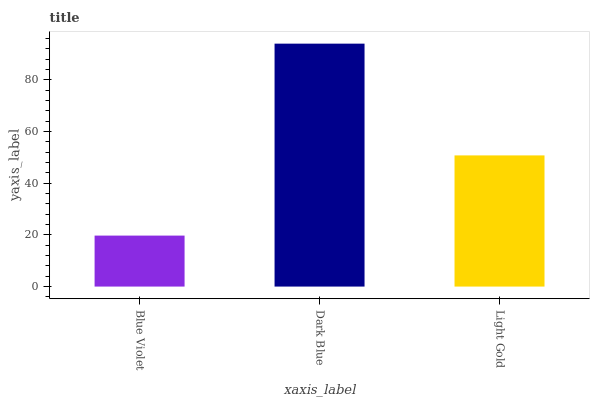Is Blue Violet the minimum?
Answer yes or no. Yes. Is Dark Blue the maximum?
Answer yes or no. Yes. Is Light Gold the minimum?
Answer yes or no. No. Is Light Gold the maximum?
Answer yes or no. No. Is Dark Blue greater than Light Gold?
Answer yes or no. Yes. Is Light Gold less than Dark Blue?
Answer yes or no. Yes. Is Light Gold greater than Dark Blue?
Answer yes or no. No. Is Dark Blue less than Light Gold?
Answer yes or no. No. Is Light Gold the high median?
Answer yes or no. Yes. Is Light Gold the low median?
Answer yes or no. Yes. Is Blue Violet the high median?
Answer yes or no. No. Is Blue Violet the low median?
Answer yes or no. No. 